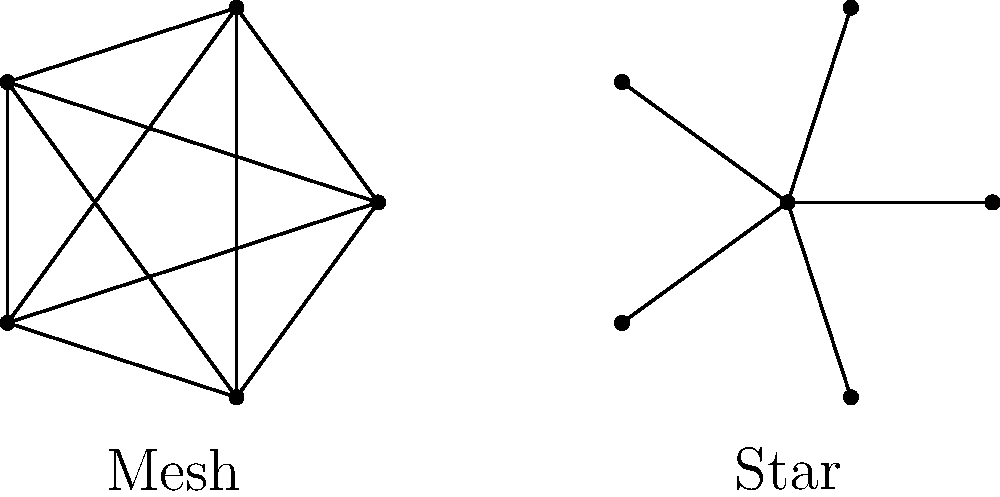În contextul topologiilor de rețea, care configurație oferă o redundanță mai mare și o rezistență sporită la defecțiuni, dar cu costuri de implementare mai ridicate: topologia mesh sau topologia star? Pentru a răspunde la această întrebare, trebuie să analizăm caracteristicile principale ale topologiilor mesh și star:

1. Topologia mesh:
   - Fiecare nod este conectat direct cu toate celelalte noduri.
   - Oferă multiple căi de comunicare între noduri.
   - Redundanță ridicată: dacă o conexiune eșuează, există alte căi disponibile.
   - Rezistență mare la defecțiuni: rețeaua poate funcționa chiar dacă unele noduri sau conexiuni eșuează.
   - Costuri ridicate de implementare din cauza numărului mare de conexiuni necesare.

2. Topologia star:
   - Toate nodurile sunt conectate la un hub sau switch central.
   - O singură cale de comunicare între noduri, prin nodul central.
   - Redundanță scăzută: dacă nodul central eșuează, întreaga rețea este afectată.
   - Rezistență mai mică la defecțiuni: eșecul nodului central poate paraliza întreaga rețea.
   - Costuri de implementare mai mici datorită numărului redus de conexiuni.

Comparând cele două topologii, observăm că topologia mesh oferă o redundanță mai mare și o rezistență sporită la defecțiuni. Acest lucru se datorează multiplelor conexiuni între noduri, care asigură căi alternative de comunicare în cazul unor defecțiuni. Cu toate acestea, aceste avantaje vin cu un cost de implementare mai ridicat, datorită numărului mare de conexiuni necesare.
Answer: Topologia mesh 